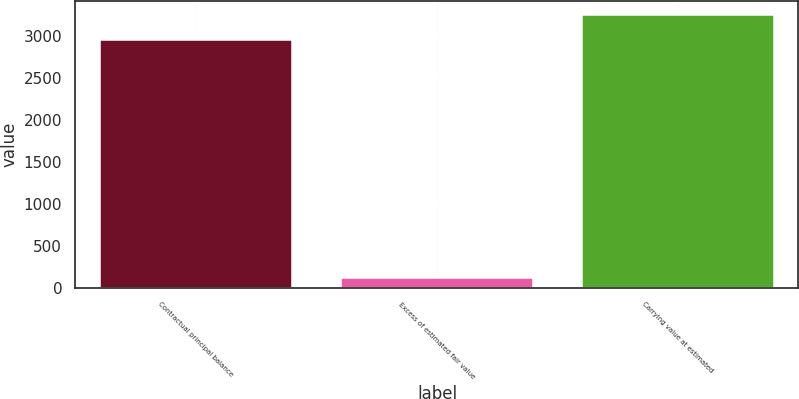<chart> <loc_0><loc_0><loc_500><loc_500><bar_chart><fcel>Contractual principal balance<fcel>Excess of estimated fair value<fcel>Carrying value at estimated<nl><fcel>2954<fcel>114<fcel>3249.4<nl></chart> 